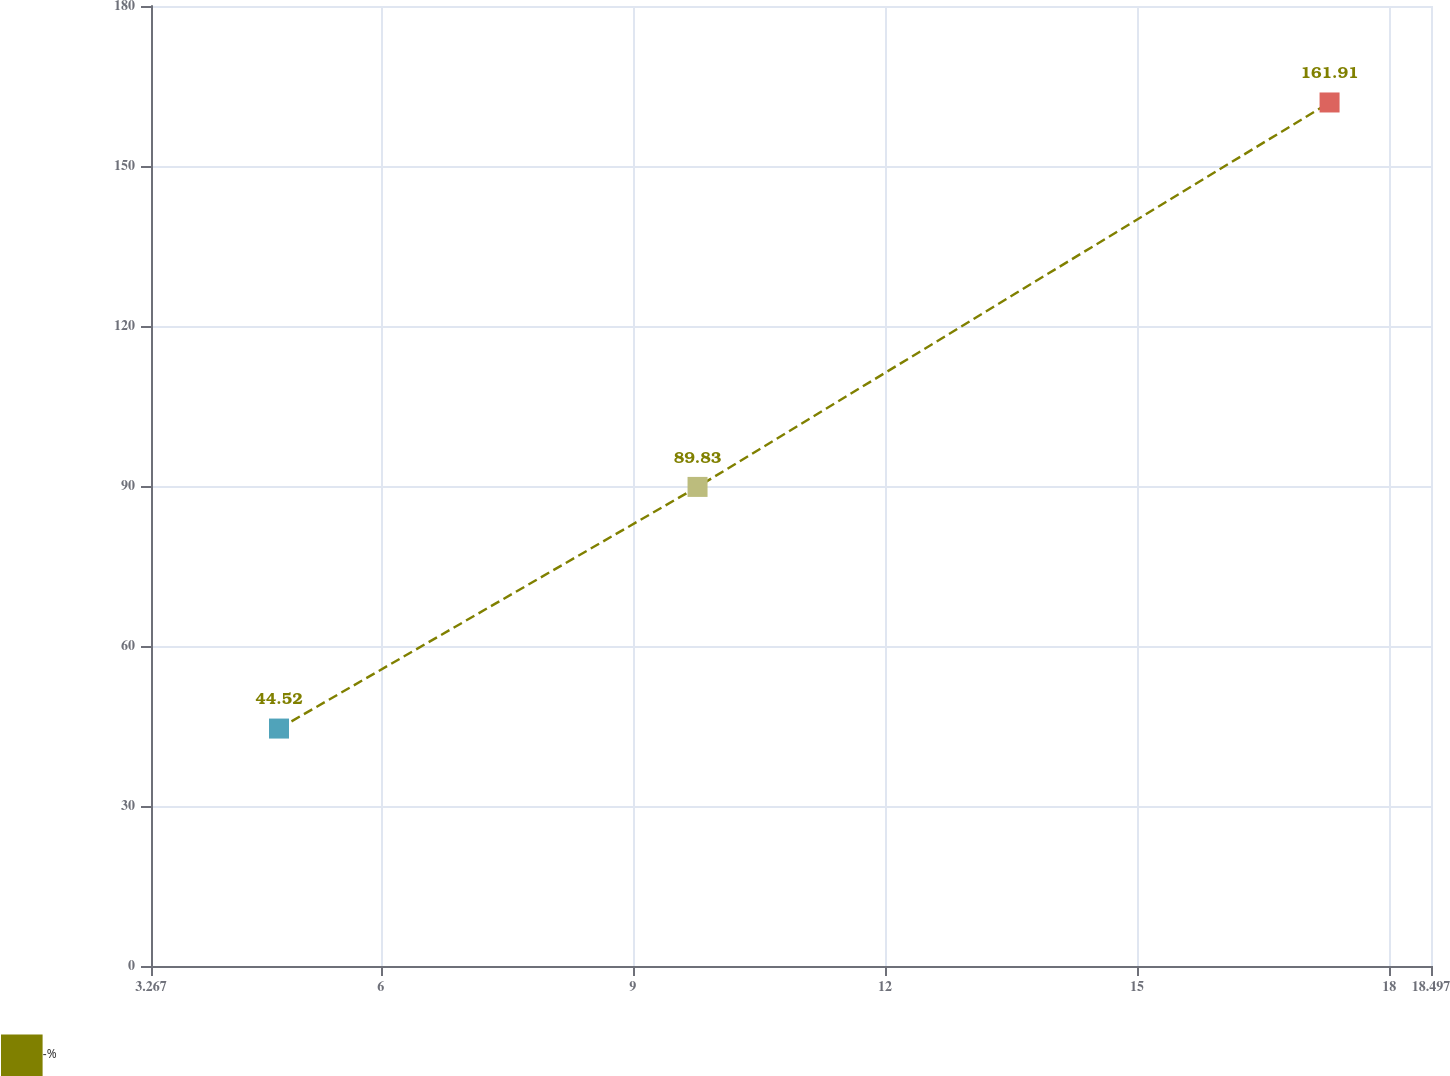Convert chart to OTSL. <chart><loc_0><loc_0><loc_500><loc_500><line_chart><ecel><fcel>-%<nl><fcel>4.79<fcel>44.52<nl><fcel>9.77<fcel>89.83<nl><fcel>17.29<fcel>161.91<nl><fcel>20.02<fcel>173.72<nl></chart> 